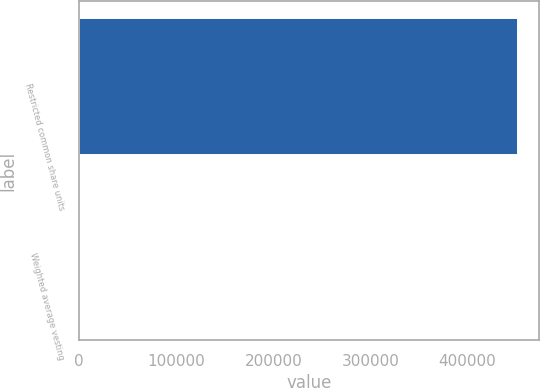Convert chart. <chart><loc_0><loc_0><loc_500><loc_500><bar_chart><fcel>Restricted common share units<fcel>Weighted average vesting<nl><fcel>450683<fcel>3.14<nl></chart> 